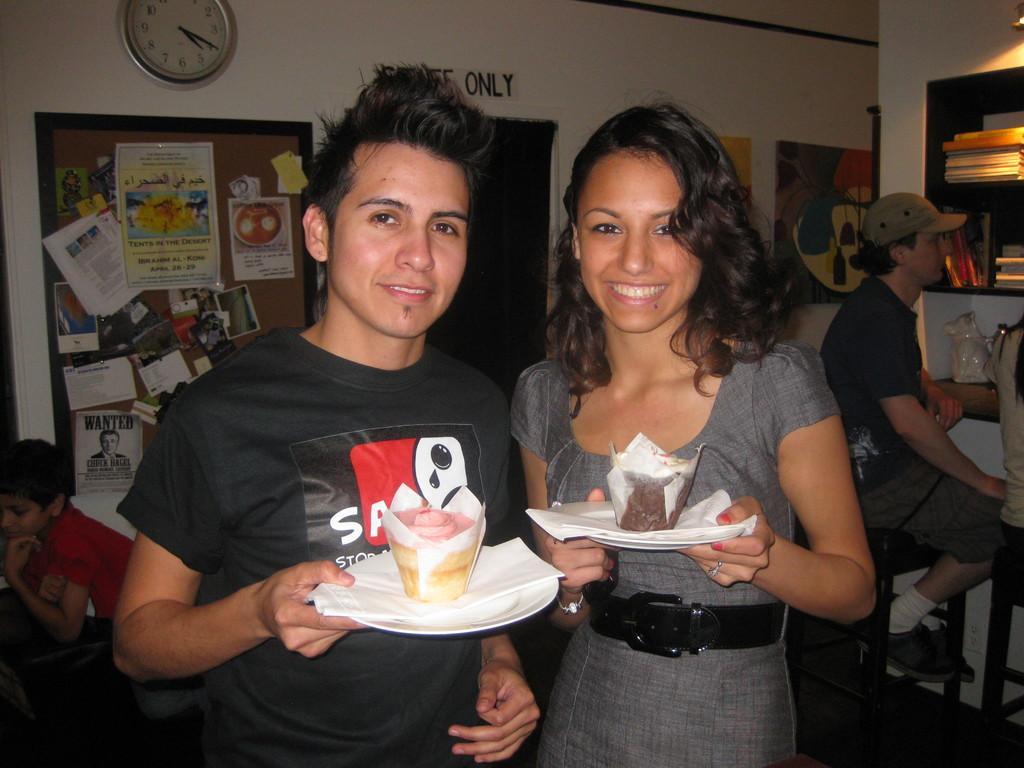Please provide a concise description of this image. This is an inside view of a room. Here I can see a woman and a man are standing, smiling and giving pose for the picture. Both are holding plates in their hands which consists of food items and tissue papers. On the right side there are two persons sitting on the chairs. In front of these people there is a table. At the top there are few books arranged in a rack. On the left side there is a boy. In the background few posters and a frame are attached to the wall. At the top of the image there is a clock. 